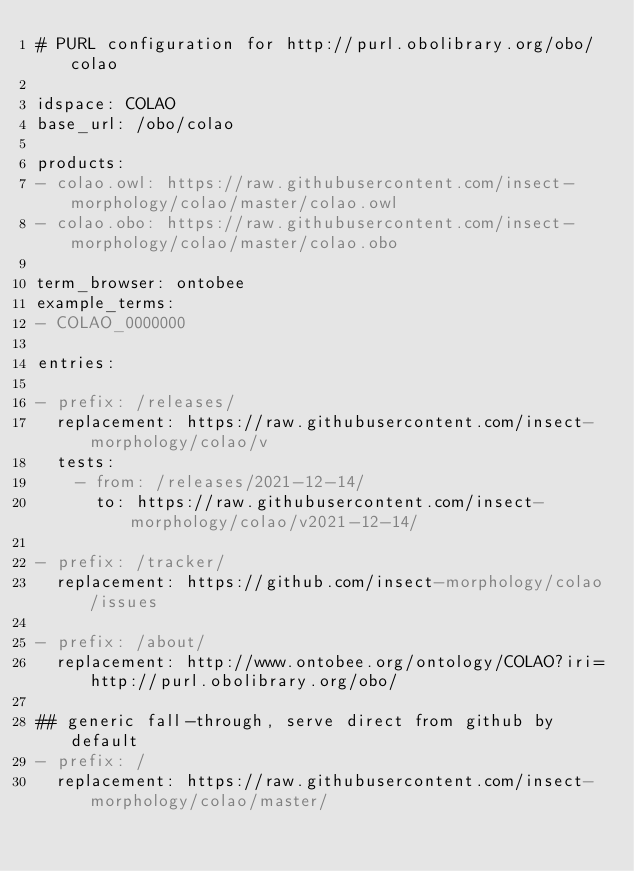Convert code to text. <code><loc_0><loc_0><loc_500><loc_500><_YAML_># PURL configuration for http://purl.obolibrary.org/obo/colao

idspace: COLAO
base_url: /obo/colao

products:
- colao.owl: https://raw.githubusercontent.com/insect-morphology/colao/master/colao.owl
- colao.obo: https://raw.githubusercontent.com/insect-morphology/colao/master/colao.obo

term_browser: ontobee
example_terms:
- COLAO_0000000

entries:

- prefix: /releases/
  replacement: https://raw.githubusercontent.com/insect-morphology/colao/v
  tests:
    - from: /releases/2021-12-14/
      to: https://raw.githubusercontent.com/insect-morphology/colao/v2021-12-14/

- prefix: /tracker/
  replacement: https://github.com/insect-morphology/colao/issues

- prefix: /about/
  replacement: http://www.ontobee.org/ontology/COLAO?iri=http://purl.obolibrary.org/obo/

## generic fall-through, serve direct from github by default
- prefix: /
  replacement: https://raw.githubusercontent.com/insect-morphology/colao/master/
</code> 